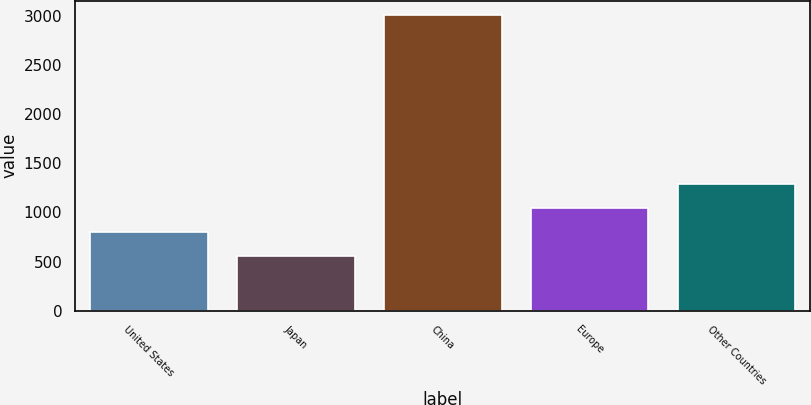Convert chart. <chart><loc_0><loc_0><loc_500><loc_500><bar_chart><fcel>United States<fcel>Japan<fcel>China<fcel>Europe<fcel>Other Countries<nl><fcel>805.5<fcel>561<fcel>3006<fcel>1050<fcel>1294.5<nl></chart> 